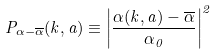Convert formula to latex. <formula><loc_0><loc_0><loc_500><loc_500>P _ { \alpha - \overline { \alpha } } ( k , a ) \equiv \left | \frac { \alpha ( k , a ) - \overline { \alpha } } { \alpha _ { 0 } } \right | ^ { 2 }</formula> 